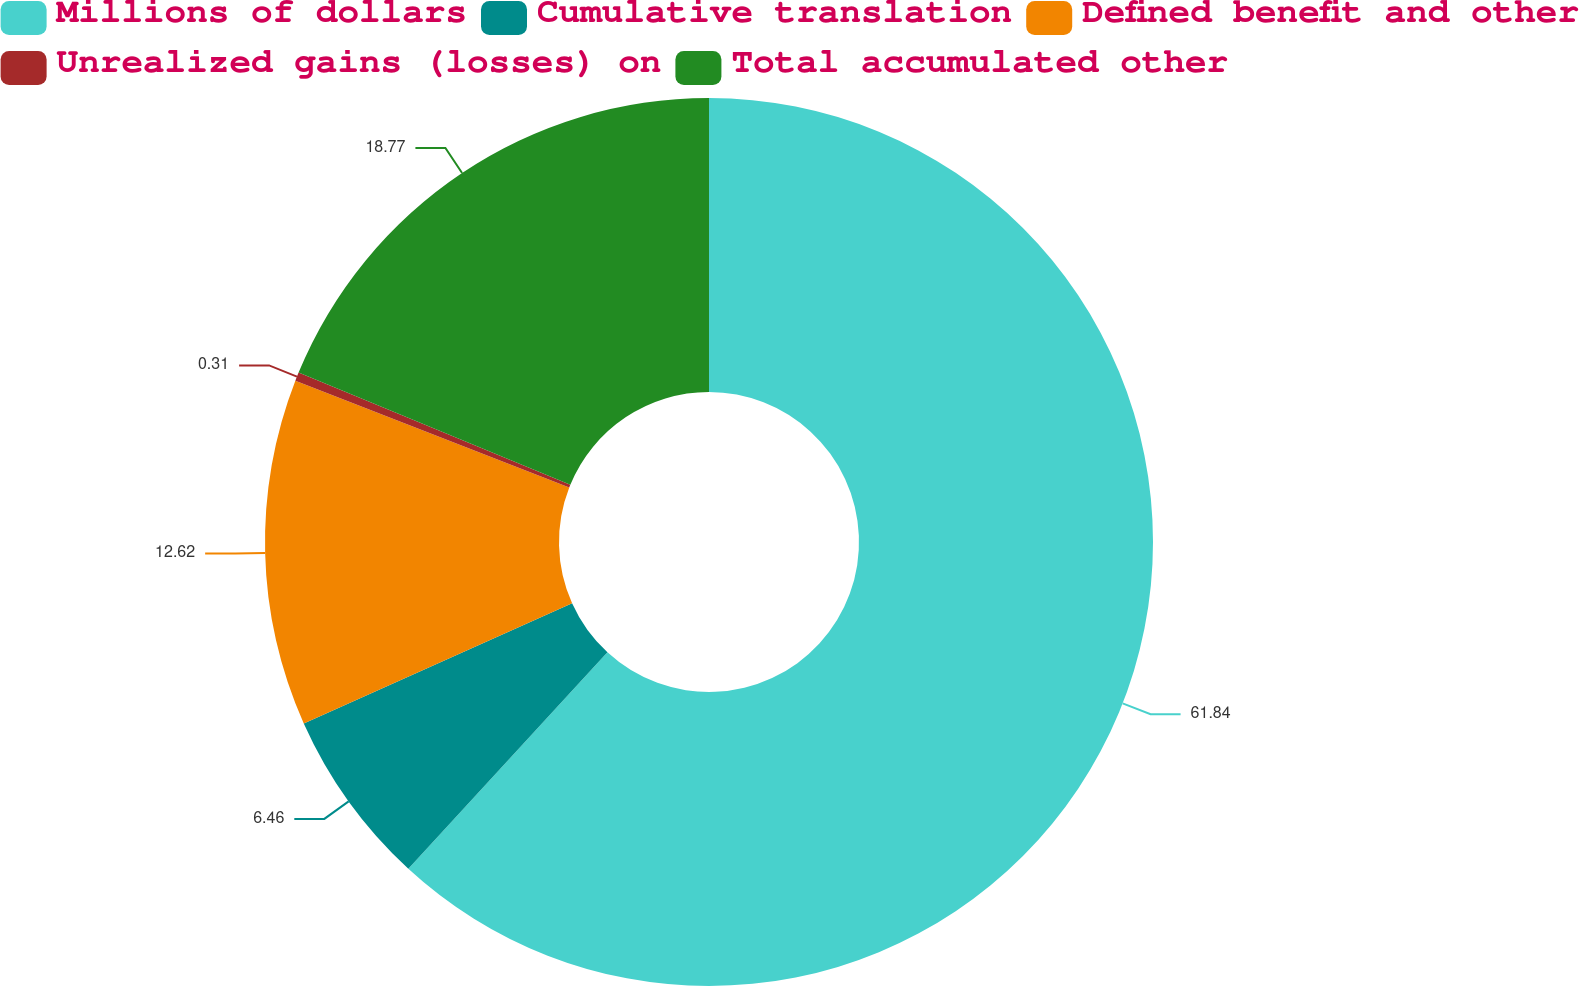Convert chart. <chart><loc_0><loc_0><loc_500><loc_500><pie_chart><fcel>Millions of dollars<fcel>Cumulative translation<fcel>Defined benefit and other<fcel>Unrealized gains (losses) on<fcel>Total accumulated other<nl><fcel>61.84%<fcel>6.46%<fcel>12.62%<fcel>0.31%<fcel>18.77%<nl></chart> 